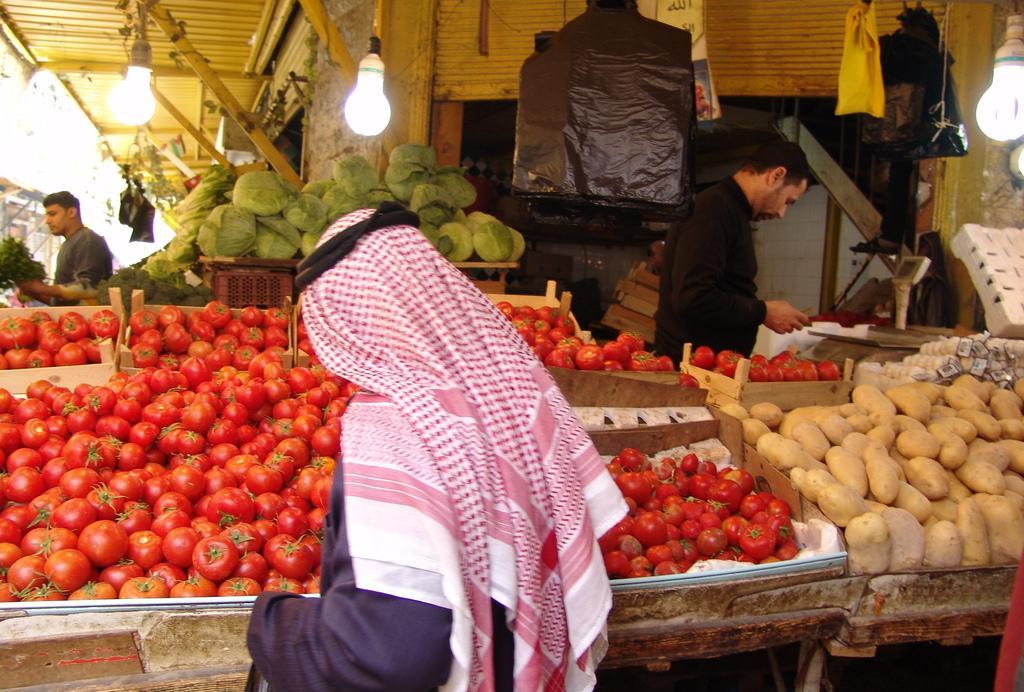Please provide a concise description of this image. In front of the picture, we see a man is wearing an Arabic head scarf. In front of him, we see a table on which the tomatoes are placed. On the right side, we see a table on which the potatoes and some other vegetables are placed. On the right side, we see a bulb and a white color object. We see a man is standing. In the middle, we see a table on which the cabbages and some other vegetables are placed. On the left side, we see a man is standing and he is holding the leafy vegetables in his hands. At the top, we see the jacket, clothes, lights and the roof of the shed. 